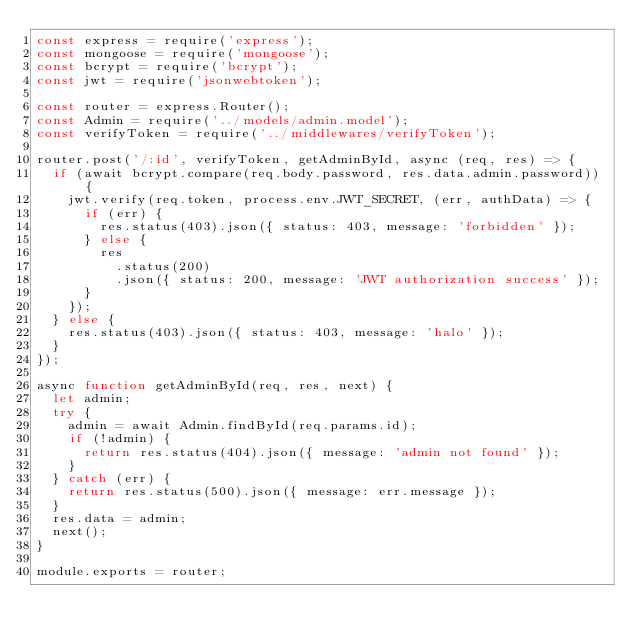Convert code to text. <code><loc_0><loc_0><loc_500><loc_500><_JavaScript_>const express = require('express');
const mongoose = require('mongoose');
const bcrypt = require('bcrypt');
const jwt = require('jsonwebtoken');

const router = express.Router();
const Admin = require('../models/admin.model');
const verifyToken = require('../middlewares/verifyToken');

router.post('/:id', verifyToken, getAdminById, async (req, res) => {
	if (await bcrypt.compare(req.body.password, res.data.admin.password)) {
		jwt.verify(req.token, process.env.JWT_SECRET, (err, authData) => {
			if (err) {
				res.status(403).json({ status: 403, message: 'forbidden' });
			} else {
				res
					.status(200)
					.json({ status: 200, message: 'JWT authorization success' });
			}
		});
	} else {
		res.status(403).json({ status: 403, message: 'halo' });
	}
});

async function getAdminById(req, res, next) {
	let admin;
	try {
		admin = await Admin.findById(req.params.id);
		if (!admin) {
			return res.status(404).json({ message: 'admin not found' });
		}
	} catch (err) {
		return res.status(500).json({ message: err.message });
	}
	res.data = admin;
	next();
}

module.exports = router;
</code> 